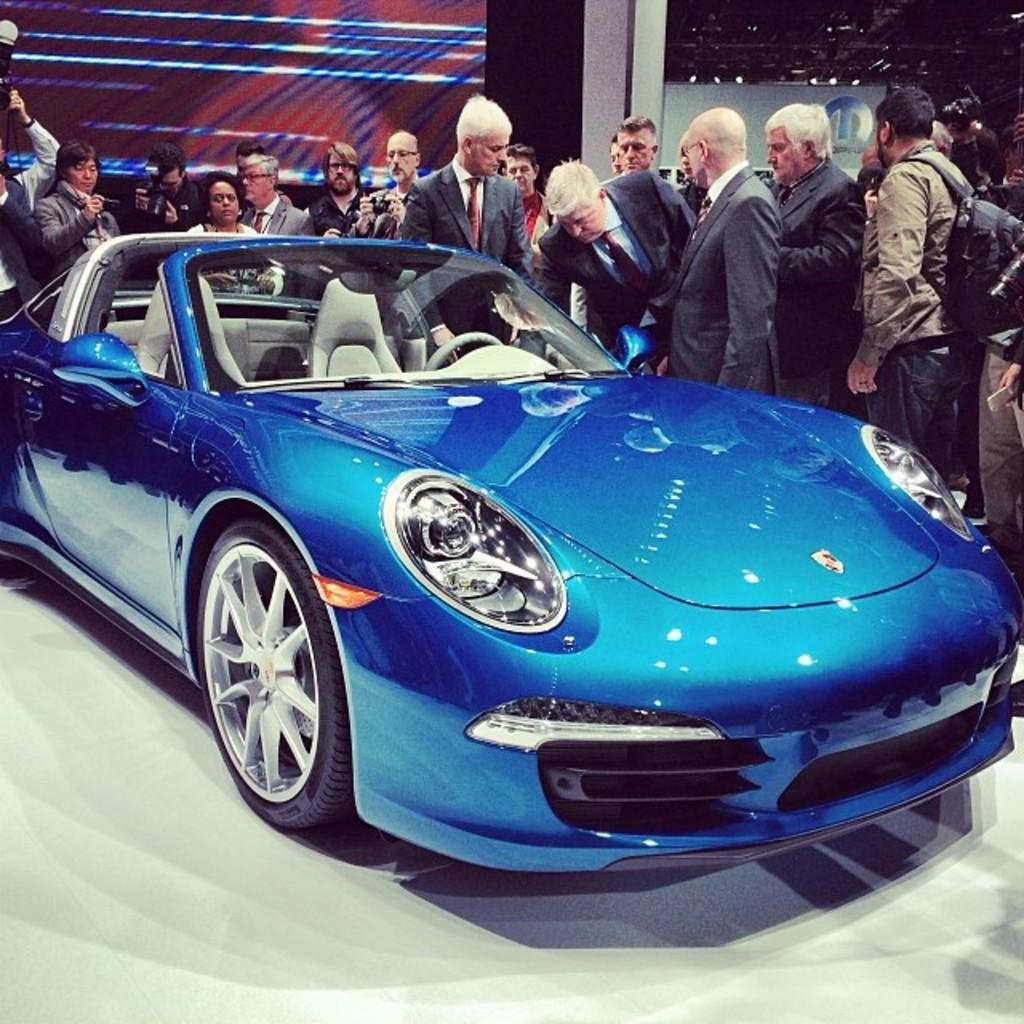What is the main subject in the center of the image? There is a car in the center of the image. What can be seen in the background of the image? There are many people standing in the background, and there is a wall visible as well. How many wristwatches can be seen on the people in the image? There is no information about wristwatches in the image, so it cannot be determined how many wristwatches are present. 